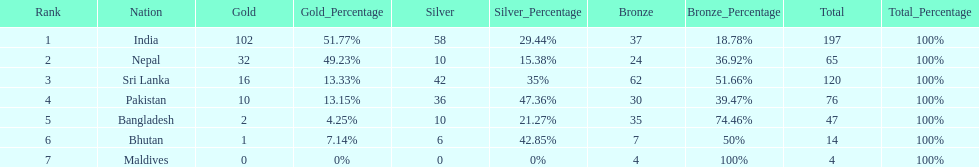Name the first country on the table? India. Can you parse all the data within this table? {'header': ['Rank', 'Nation', 'Gold', 'Gold_Percentage', 'Silver', 'Silver_Percentage', 'Bronze', 'Bronze_Percentage', 'Total', 'Total_Percentage'], 'rows': [['1', 'India', '102', '51.77%', '58', '29.44%', '37', '18.78%', '197', '100%'], ['2', 'Nepal', '32', '49.23%', '10', '15.38%', '24', '36.92%', '65', '100%'], ['3', 'Sri Lanka', '16', '13.33%', '42', '35%', '62', '51.66%', '120', '100%'], ['4', 'Pakistan', '10', '13.15%', '36', '47.36%', '30', '39.47%', '76', '100%'], ['5', 'Bangladesh', '2', '4.25%', '10', '21.27%', '35', '74.46%', '47', '100%'], ['6', 'Bhutan', '1', '7.14%', '6', '42.85%', '7', '50%', '14', '100%'], ['7', 'Maldives', '0', '0%', '0', '0%', '4', '100%', '4', '100%']]} 